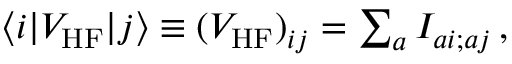Convert formula to latex. <formula><loc_0><loc_0><loc_500><loc_500>\begin{array} { r } { \langle i | V _ { H F } | j \rangle \equiv ( V _ { H F } ) _ { i j } = \sum _ { a } I _ { a i ; a j } \, , } \end{array}</formula> 